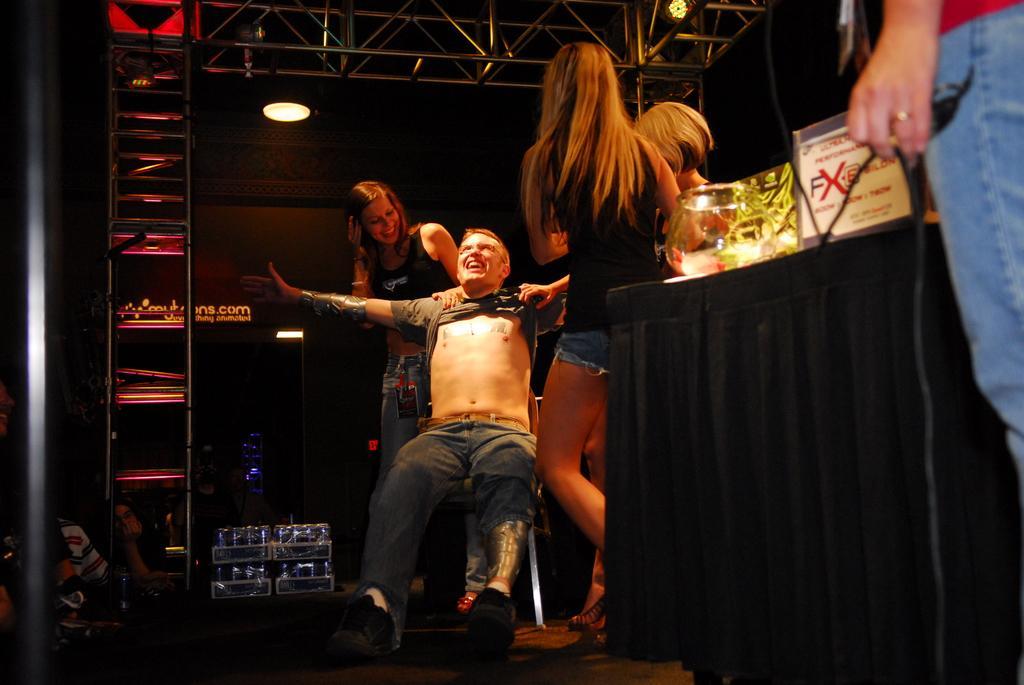Please provide a concise description of this image. In this image there is a person sitting on the chair, there are three persons standing, there is a person truncated towards the right of the image, there are objects on the surface, there is a pole truncated towards the left of the image, there are persons truncated towards the left of the image, there are lights, there is text on the wall, there is a wire. 